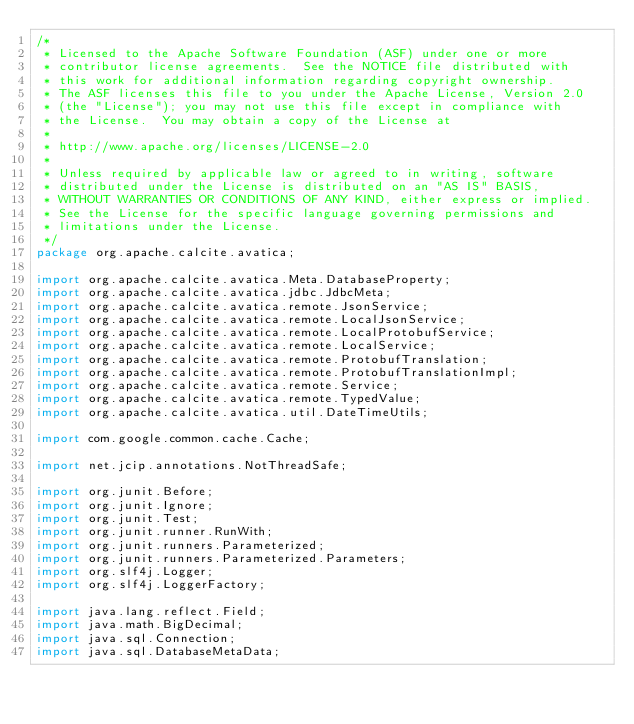Convert code to text. <code><loc_0><loc_0><loc_500><loc_500><_Java_>/*
 * Licensed to the Apache Software Foundation (ASF) under one or more
 * contributor license agreements.  See the NOTICE file distributed with
 * this work for additional information regarding copyright ownership.
 * The ASF licenses this file to you under the Apache License, Version 2.0
 * (the "License"); you may not use this file except in compliance with
 * the License.  You may obtain a copy of the License at
 *
 * http://www.apache.org/licenses/LICENSE-2.0
 *
 * Unless required by applicable law or agreed to in writing, software
 * distributed under the License is distributed on an "AS IS" BASIS,
 * WITHOUT WARRANTIES OR CONDITIONS OF ANY KIND, either express or implied.
 * See the License for the specific language governing permissions and
 * limitations under the License.
 */
package org.apache.calcite.avatica;

import org.apache.calcite.avatica.Meta.DatabaseProperty;
import org.apache.calcite.avatica.jdbc.JdbcMeta;
import org.apache.calcite.avatica.remote.JsonService;
import org.apache.calcite.avatica.remote.LocalJsonService;
import org.apache.calcite.avatica.remote.LocalProtobufService;
import org.apache.calcite.avatica.remote.LocalService;
import org.apache.calcite.avatica.remote.ProtobufTranslation;
import org.apache.calcite.avatica.remote.ProtobufTranslationImpl;
import org.apache.calcite.avatica.remote.Service;
import org.apache.calcite.avatica.remote.TypedValue;
import org.apache.calcite.avatica.util.DateTimeUtils;

import com.google.common.cache.Cache;

import net.jcip.annotations.NotThreadSafe;

import org.junit.Before;
import org.junit.Ignore;
import org.junit.Test;
import org.junit.runner.RunWith;
import org.junit.runners.Parameterized;
import org.junit.runners.Parameterized.Parameters;
import org.slf4j.Logger;
import org.slf4j.LoggerFactory;

import java.lang.reflect.Field;
import java.math.BigDecimal;
import java.sql.Connection;
import java.sql.DatabaseMetaData;</code> 